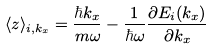<formula> <loc_0><loc_0><loc_500><loc_500>\langle z \rangle _ { i , k _ { x } } = \frac { \hbar { k } _ { x } } { m \omega } - \frac { 1 } { \hbar { \omega } } \frac { \partial E _ { i } ( k _ { x } ) } { \partial k _ { x } }</formula> 